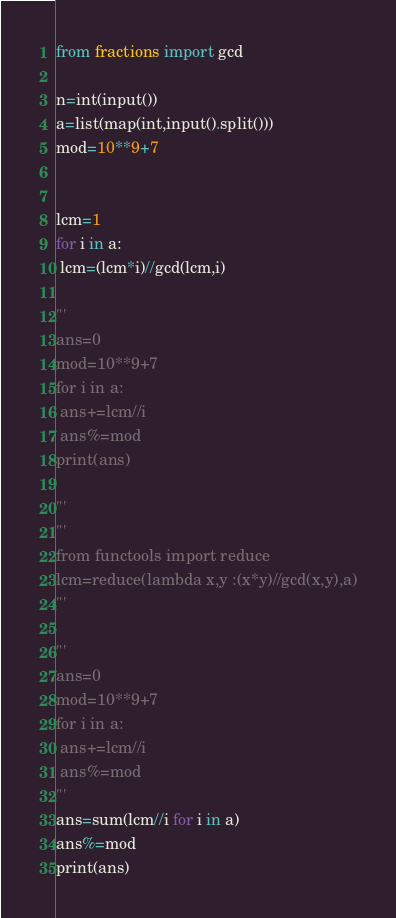Convert code to text. <code><loc_0><loc_0><loc_500><loc_500><_Python_>from fractions import gcd

n=int(input())
a=list(map(int,input().split()))
mod=10**9+7


lcm=1
for i in a:
 lcm=(lcm*i)//gcd(lcm,i)

'''
ans=0
mod=10**9+7
for i in a:
 ans+=lcm//i
 ans%=mod
print(ans)

'''
'''
from functools import reduce
lcm=reduce(lambda x,y :(x*y)//gcd(x,y),a)
'''

'''
ans=0
mod=10**9+7
for i in a:
 ans+=lcm//i
 ans%=mod
'''
ans=sum(lcm//i for i in a)
ans%=mod
print(ans)</code> 